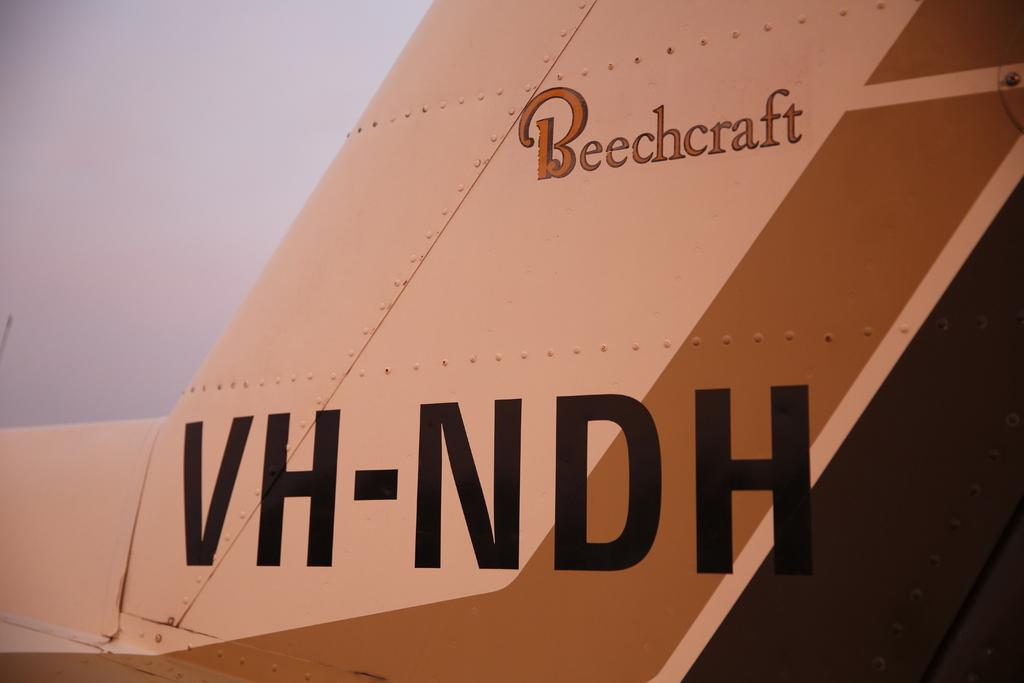<image>
Write a terse but informative summary of the picture. A wing of a plane in beige and tan with Beechcraft and VH-NDH written on the side. 